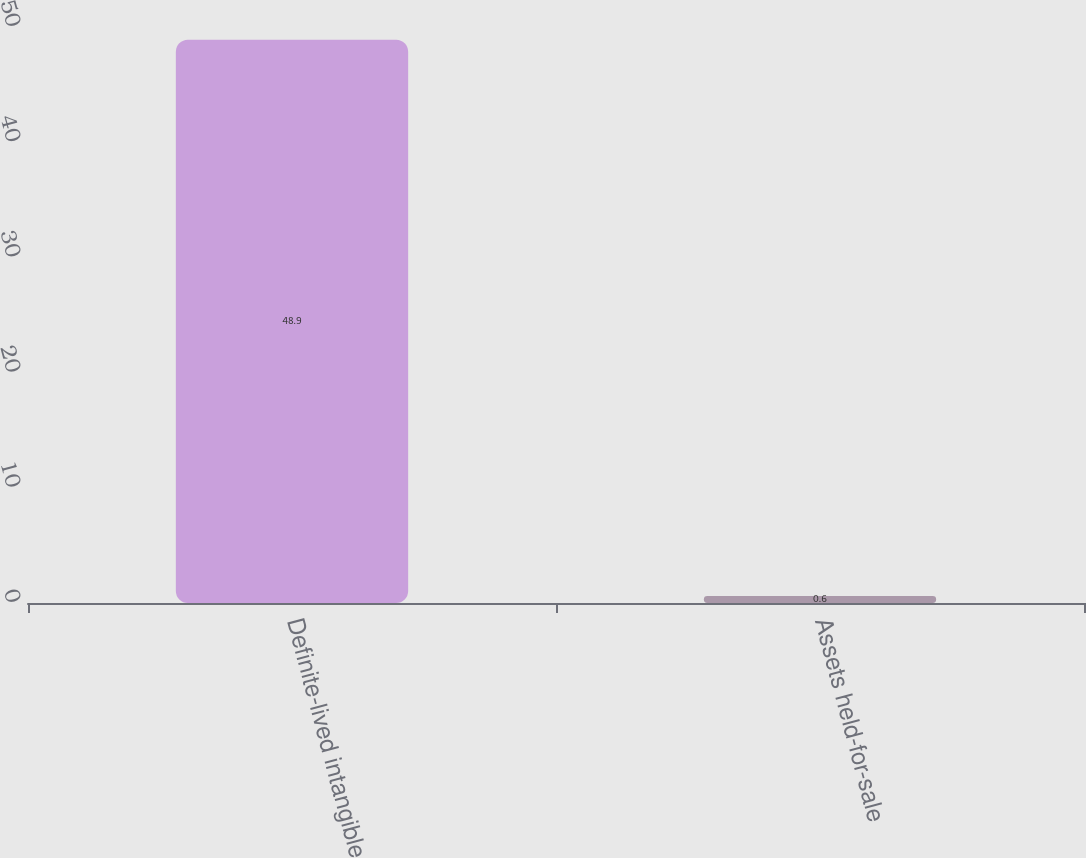Convert chart. <chart><loc_0><loc_0><loc_500><loc_500><bar_chart><fcel>Definite-lived intangible<fcel>Assets held-for-sale<nl><fcel>48.9<fcel>0.6<nl></chart> 